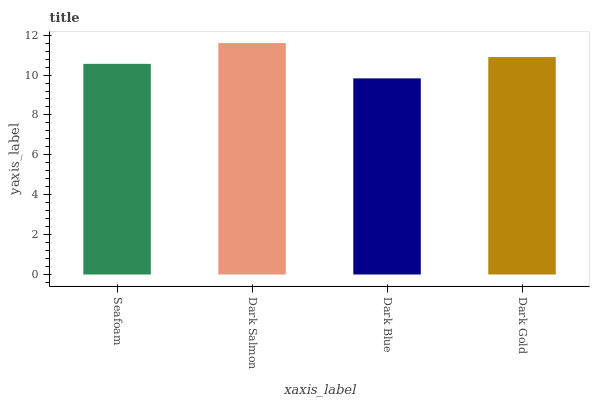Is Dark Blue the minimum?
Answer yes or no. Yes. Is Dark Salmon the maximum?
Answer yes or no. Yes. Is Dark Salmon the minimum?
Answer yes or no. No. Is Dark Blue the maximum?
Answer yes or no. No. Is Dark Salmon greater than Dark Blue?
Answer yes or no. Yes. Is Dark Blue less than Dark Salmon?
Answer yes or no. Yes. Is Dark Blue greater than Dark Salmon?
Answer yes or no. No. Is Dark Salmon less than Dark Blue?
Answer yes or no. No. Is Dark Gold the high median?
Answer yes or no. Yes. Is Seafoam the low median?
Answer yes or no. Yes. Is Dark Blue the high median?
Answer yes or no. No. Is Dark Gold the low median?
Answer yes or no. No. 